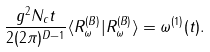Convert formula to latex. <formula><loc_0><loc_0><loc_500><loc_500>\frac { g ^ { 2 } N _ { c } t } { 2 ( 2 \pi ) ^ { D - 1 } } \langle R _ { \omega } ^ { ( B ) } | R _ { \omega } ^ { ( B ) } \rangle = \omega ^ { ( 1 ) } ( t ) .</formula> 